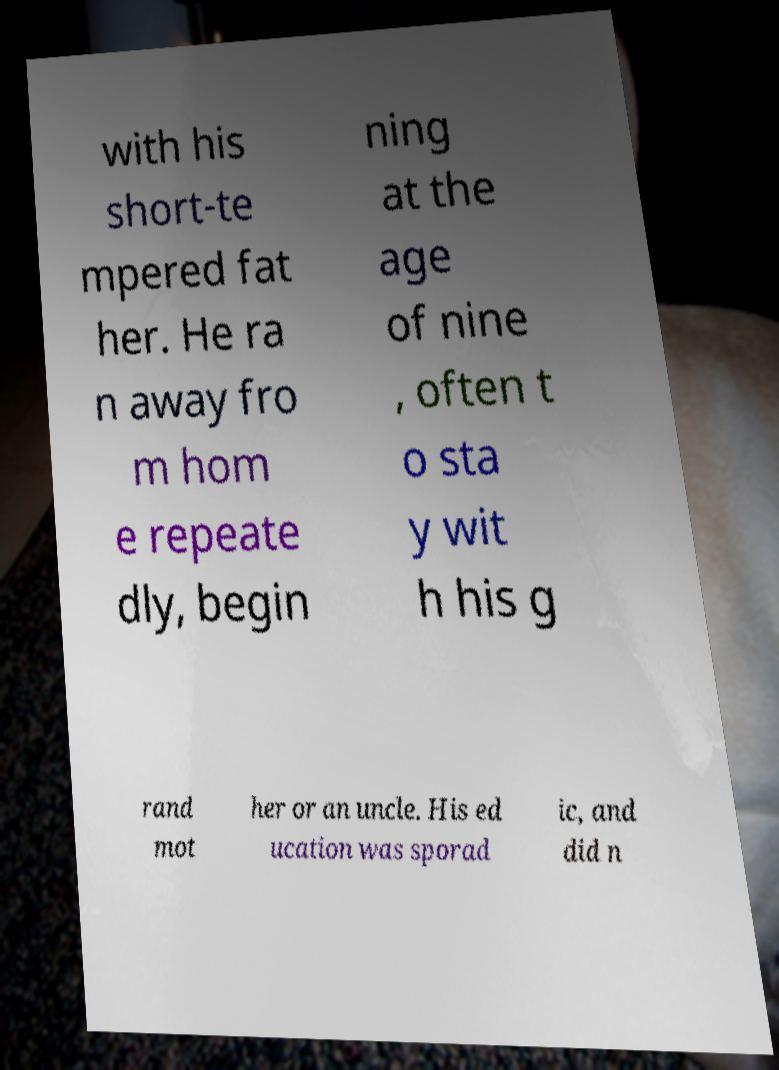For documentation purposes, I need the text within this image transcribed. Could you provide that? with his short-te mpered fat her. He ra n away fro m hom e repeate dly, begin ning at the age of nine , often t o sta y wit h his g rand mot her or an uncle. His ed ucation was sporad ic, and did n 